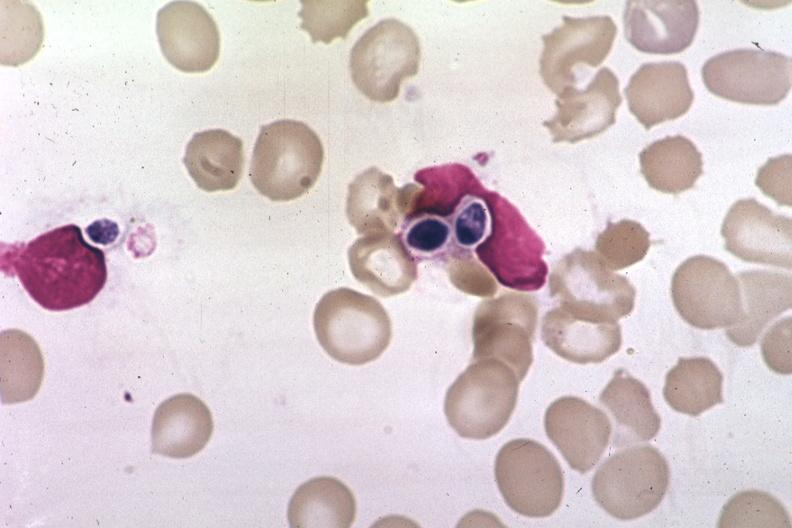s hematologic present?
Answer the question using a single word or phrase. Yes 